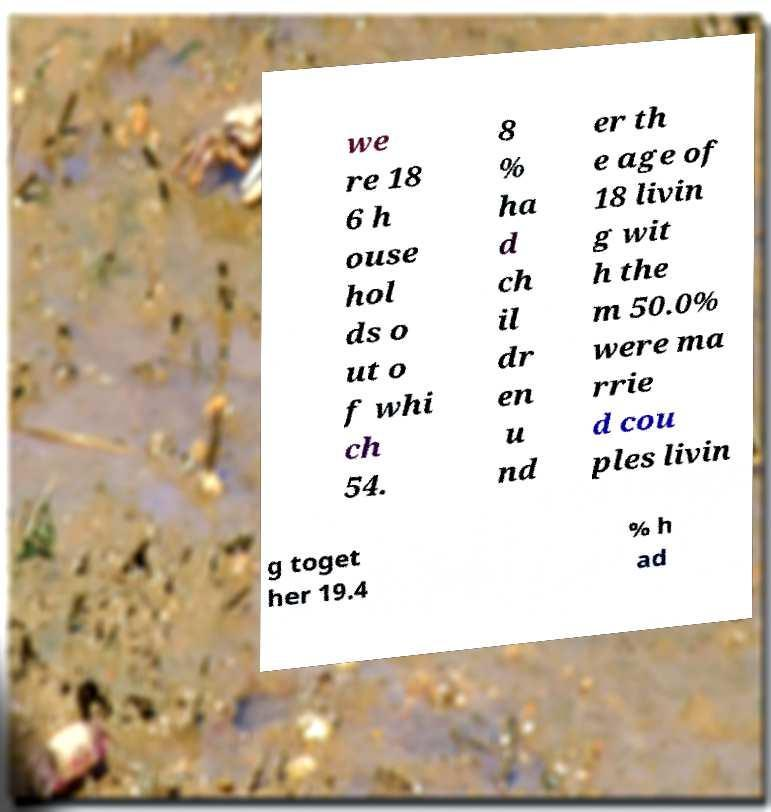Could you assist in decoding the text presented in this image and type it out clearly? we re 18 6 h ouse hol ds o ut o f whi ch 54. 8 % ha d ch il dr en u nd er th e age of 18 livin g wit h the m 50.0% were ma rrie d cou ples livin g toget her 19.4 % h ad 